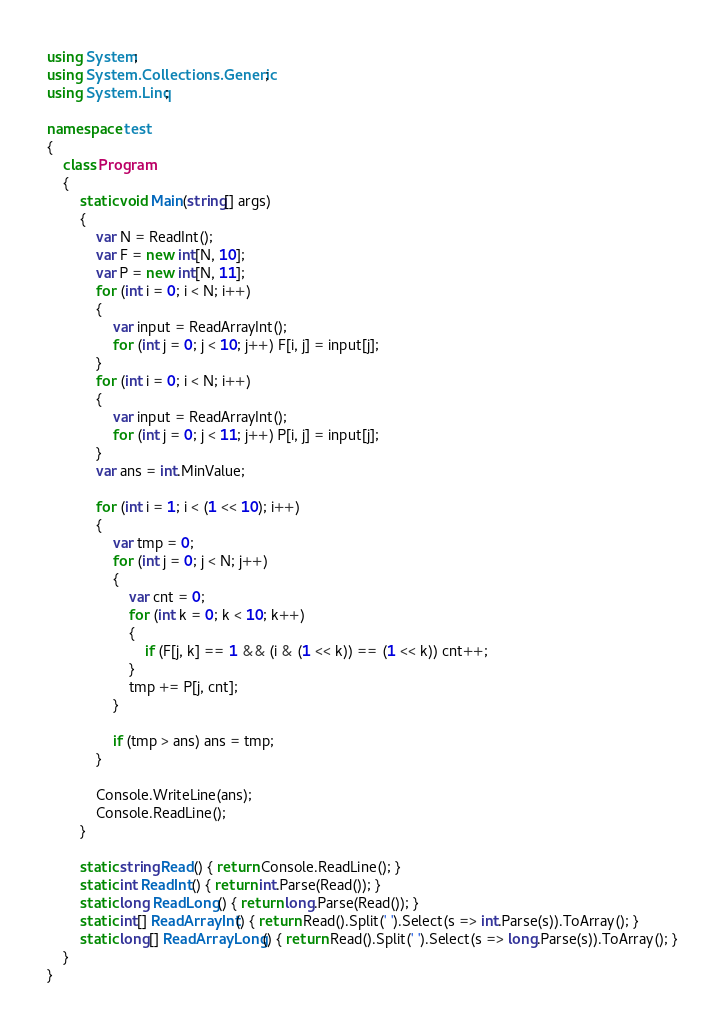Convert code to text. <code><loc_0><loc_0><loc_500><loc_500><_C#_>using System;
using System.Collections.Generic;
using System.Linq;

namespace test
{
    class Program
    {
        static void Main(string[] args)
        {
            var N = ReadInt();
            var F = new int[N, 10];
            var P = new int[N, 11];
            for (int i = 0; i < N; i++)
            {
                var input = ReadArrayInt();
                for (int j = 0; j < 10; j++) F[i, j] = input[j];
            }
            for (int i = 0; i < N; i++)
            {
                var input = ReadArrayInt();
                for (int j = 0; j < 11; j++) P[i, j] = input[j];
            }
            var ans = int.MinValue;

            for (int i = 1; i < (1 << 10); i++)
            {
                var tmp = 0;
                for (int j = 0; j < N; j++)
                {
                    var cnt = 0;
                    for (int k = 0; k < 10; k++)
                    {
                        if (F[j, k] == 1 && (i & (1 << k)) == (1 << k)) cnt++;
                    }
                    tmp += P[j, cnt];
                }

                if (tmp > ans) ans = tmp;
            }

            Console.WriteLine(ans);
            Console.ReadLine();
        }

        static string Read() { return Console.ReadLine(); }
        static int ReadInt() { return int.Parse(Read()); }
        static long ReadLong() { return long.Parse(Read()); }
        static int[] ReadArrayInt() { return Read().Split(' ').Select(s => int.Parse(s)).ToArray(); }
        static long[] ReadArrayLong() { return Read().Split(' ').Select(s => long.Parse(s)).ToArray(); }
    }
}</code> 